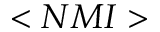Convert formula to latex. <formula><loc_0><loc_0><loc_500><loc_500>< N M I ></formula> 